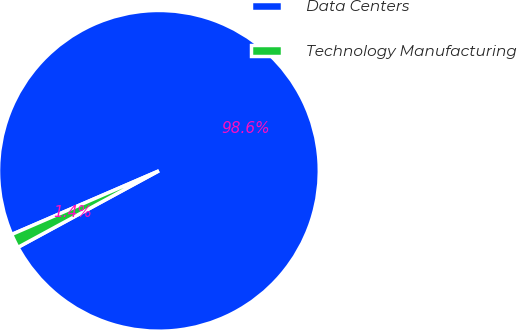<chart> <loc_0><loc_0><loc_500><loc_500><pie_chart><fcel>Data Centers<fcel>Technology Manufacturing<nl><fcel>98.58%<fcel>1.42%<nl></chart> 